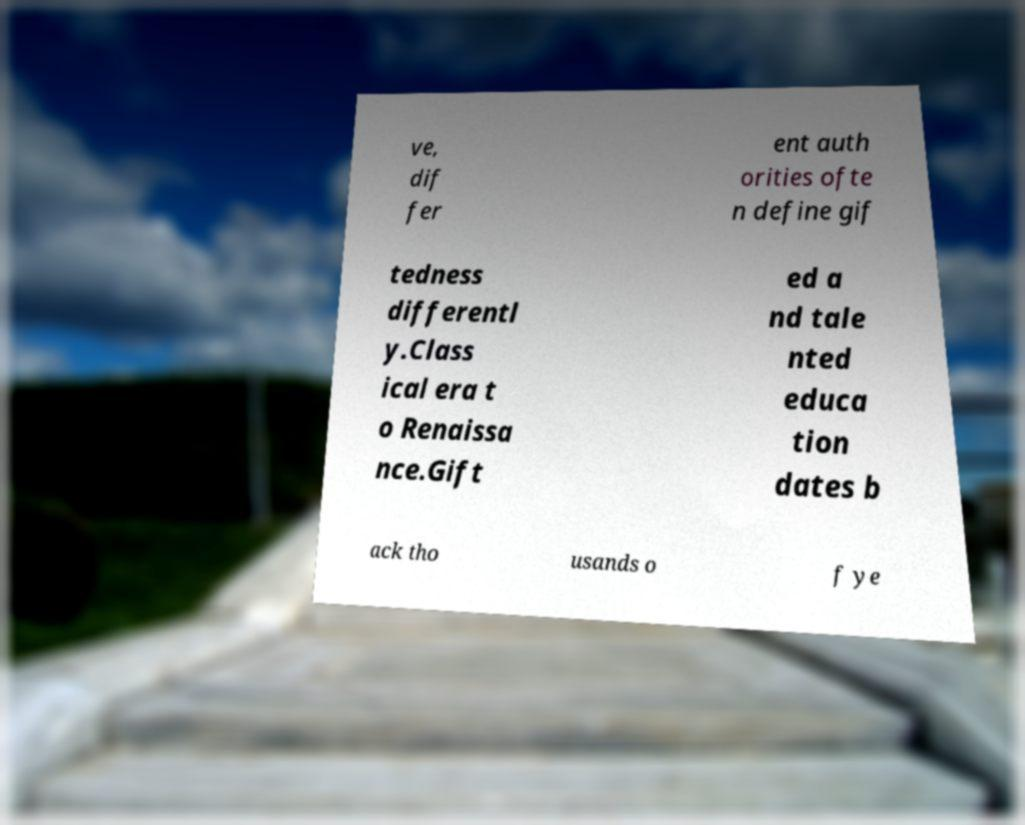I need the written content from this picture converted into text. Can you do that? ve, dif fer ent auth orities ofte n define gif tedness differentl y.Class ical era t o Renaissa nce.Gift ed a nd tale nted educa tion dates b ack tho usands o f ye 